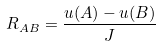<formula> <loc_0><loc_0><loc_500><loc_500>R _ { A B } = \frac { u ( A ) - u ( B ) } J</formula> 